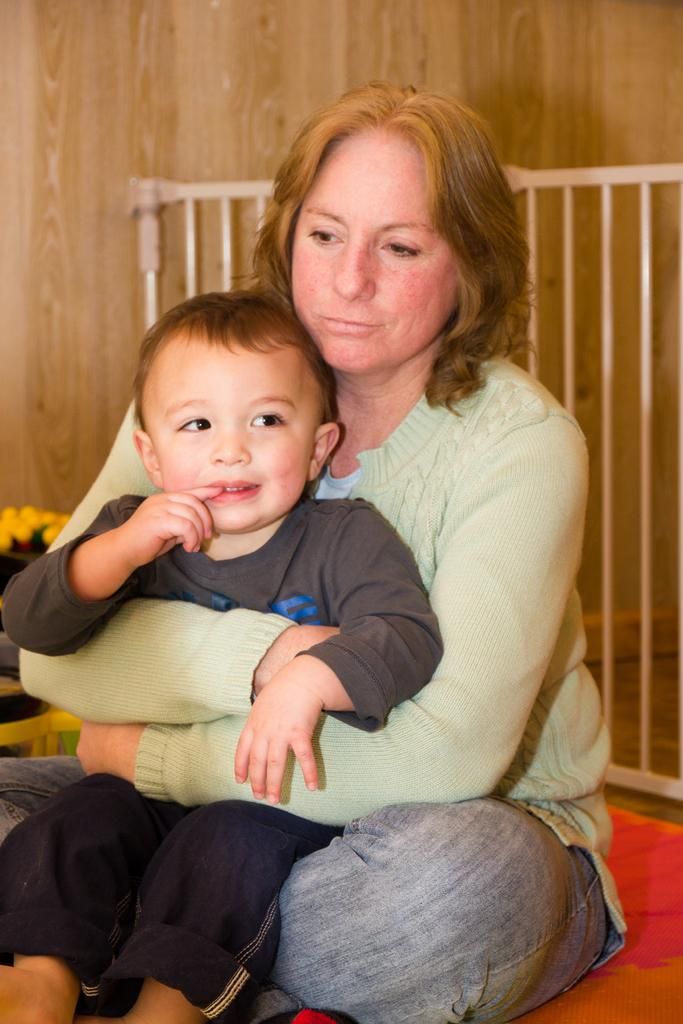Who is the main subject in the image? There is a woman in the image. What is the woman doing in the image? The woman is sitting on the floor and holding a kid. What can be seen in the background of the image? There is a railing and a wall behind the woman. What type of ship can be seen in the background of the image? There is no ship present in the image; it features a woman sitting on the floor holding a kid, with a railing and a wall in the background. What kind of fowl is sitting on the woman's shoulder in the image? There is no fowl present in the image; it only shows a woman holding a kid, with a railing and a wall in the background. 